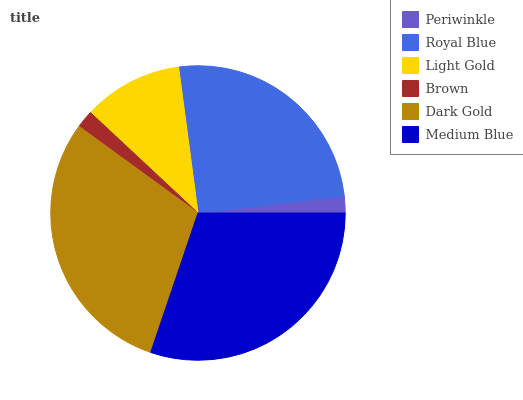Is Periwinkle the minimum?
Answer yes or no. Yes. Is Medium Blue the maximum?
Answer yes or no. Yes. Is Royal Blue the minimum?
Answer yes or no. No. Is Royal Blue the maximum?
Answer yes or no. No. Is Royal Blue greater than Periwinkle?
Answer yes or no. Yes. Is Periwinkle less than Royal Blue?
Answer yes or no. Yes. Is Periwinkle greater than Royal Blue?
Answer yes or no. No. Is Royal Blue less than Periwinkle?
Answer yes or no. No. Is Royal Blue the high median?
Answer yes or no. Yes. Is Light Gold the low median?
Answer yes or no. Yes. Is Medium Blue the high median?
Answer yes or no. No. Is Brown the low median?
Answer yes or no. No. 